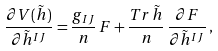Convert formula to latex. <formula><loc_0><loc_0><loc_500><loc_500>\frac { \partial V ( \tilde { h } ) } { \partial \tilde { h } ^ { I J } } = \frac { g _ { I J } } { n } \, F + \frac { T r \, \tilde { h } } { n } \, \frac { \partial F } { \partial \tilde { h } ^ { I J } } \, ,</formula> 